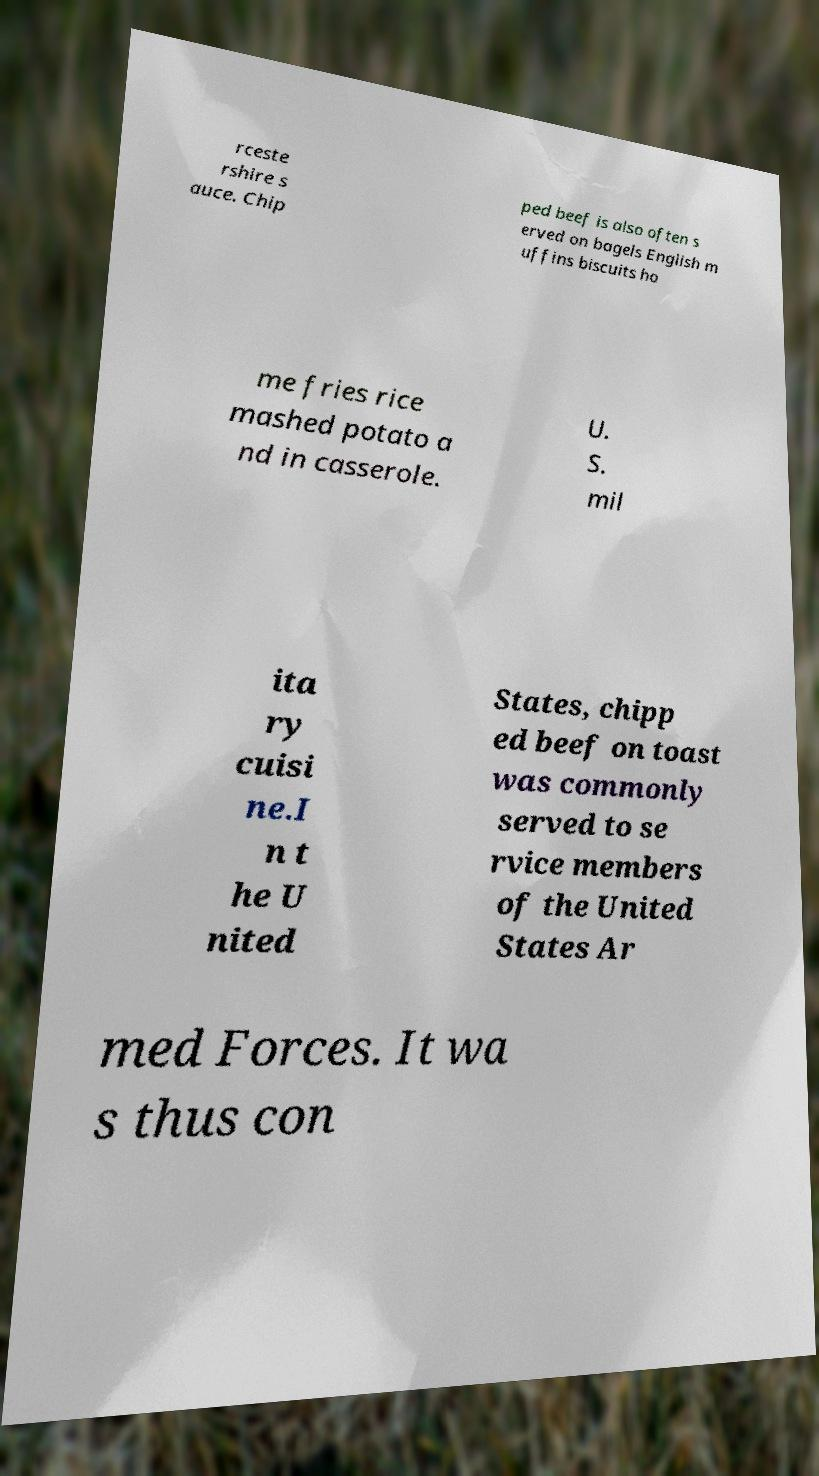Can you accurately transcribe the text from the provided image for me? rceste rshire s auce. Chip ped beef is also often s erved on bagels English m uffins biscuits ho me fries rice mashed potato a nd in casserole. U. S. mil ita ry cuisi ne.I n t he U nited States, chipp ed beef on toast was commonly served to se rvice members of the United States Ar med Forces. It wa s thus con 